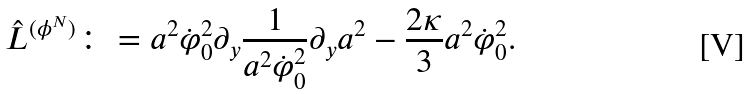<formula> <loc_0><loc_0><loc_500><loc_500>\hat { L } ^ { ( \phi ^ { N } ) } \colon = a ^ { 2 } \dot { \varphi } _ { 0 } ^ { 2 } \partial _ { y } { \frac { 1 } { a ^ { 2 } \dot { \varphi } _ { 0 } ^ { 2 } } } \partial _ { y } a ^ { 2 } - { \frac { 2 \kappa } { 3 } } a ^ { 2 } \dot { \varphi } _ { 0 } ^ { 2 } .</formula> 